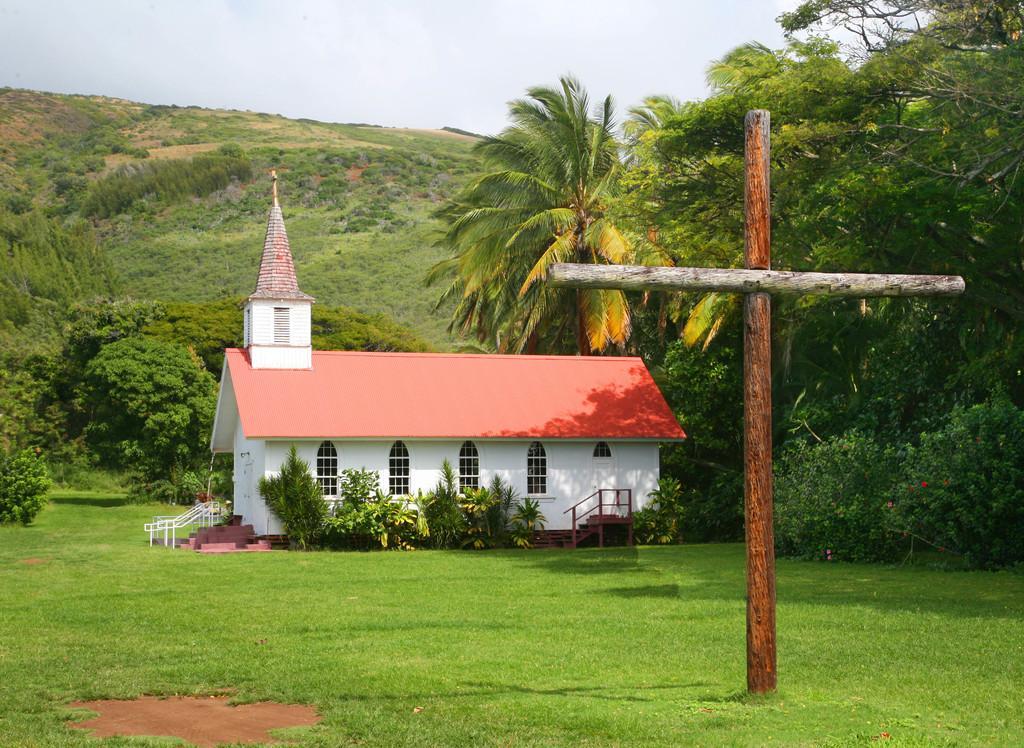Please provide a concise description of this image. In this picture I see the grass in front and I see 2 wooden sticks on the right side of this image and in the middle of this image I see a house and number of trees. In the background I see the sky. 